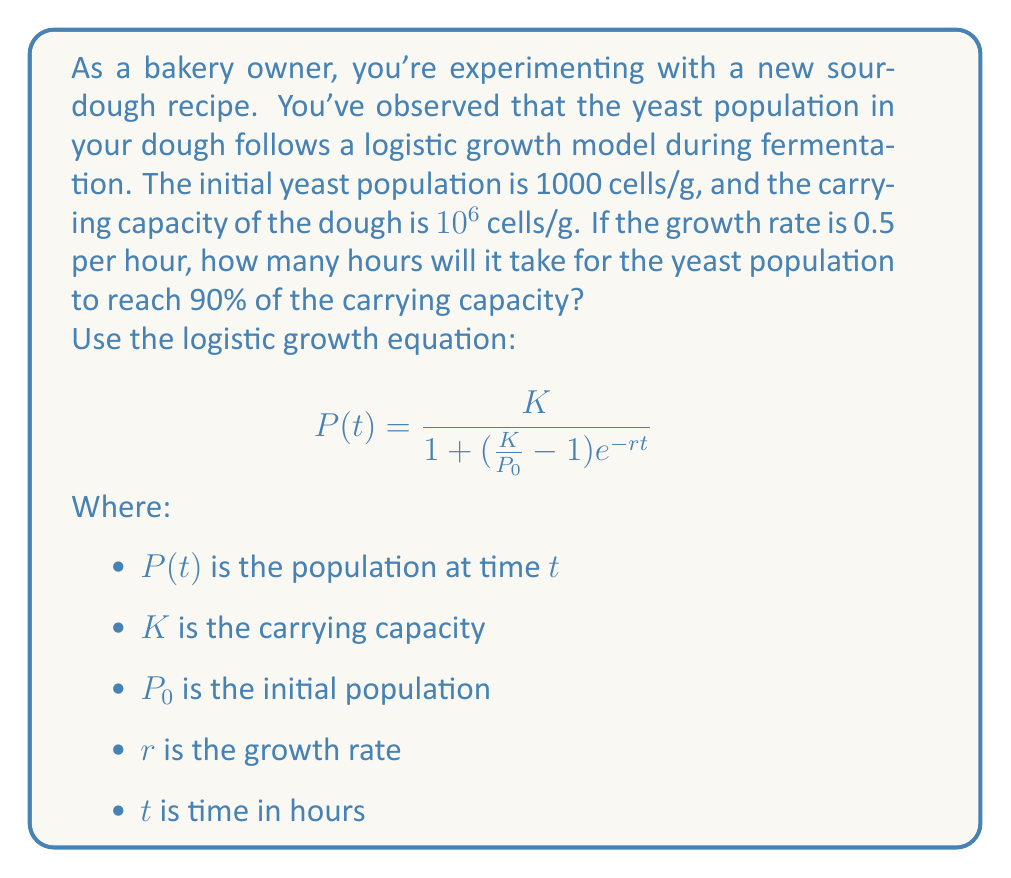Help me with this question. Let's approach this step-by-step:

1) We're given:
   $K = 10^6$ cells/g
   $P_0 = 1000$ cells/g
   $r = 0.5$ per hour

2) We want to find $t$ when $P(t) = 0.9K = 0.9 \times 10^6 = 900,000$ cells/g

3) Let's substitute these values into the logistic growth equation:

   $$900,000 = \frac{10^6}{1 + (\frac{10^6}{1000} - 1)e^{-0.5t}}$$

4) Simplify:
   $$900,000 = \frac{10^6}{1 + 999e^{-0.5t}}$$

5) Divide both sides by 10^6:
   $$0.9 = \frac{1}{1 + 999e^{-0.5t}}$$

6) Take the reciprocal of both sides:
   $$\frac{10}{9} = 1 + 999e^{-0.5t}$$

7) Subtract 1 from both sides:
   $$\frac{1}{9} = 999e^{-0.5t}$$

8) Divide both sides by 999:
   $$\frac{1}{8991} = e^{-0.5t}$$

9) Take the natural log of both sides:
   $$\ln(\frac{1}{8991}) = -0.5t$$

10) Divide both sides by -0.5:
    $$\frac{\ln(8991)}{0.5} = t$$

11) Calculate:
    $$t \approx 18.21$$

Therefore, it will take approximately 18.21 hours for the yeast population to reach 90% of the carrying capacity.
Answer: 18.21 hours 